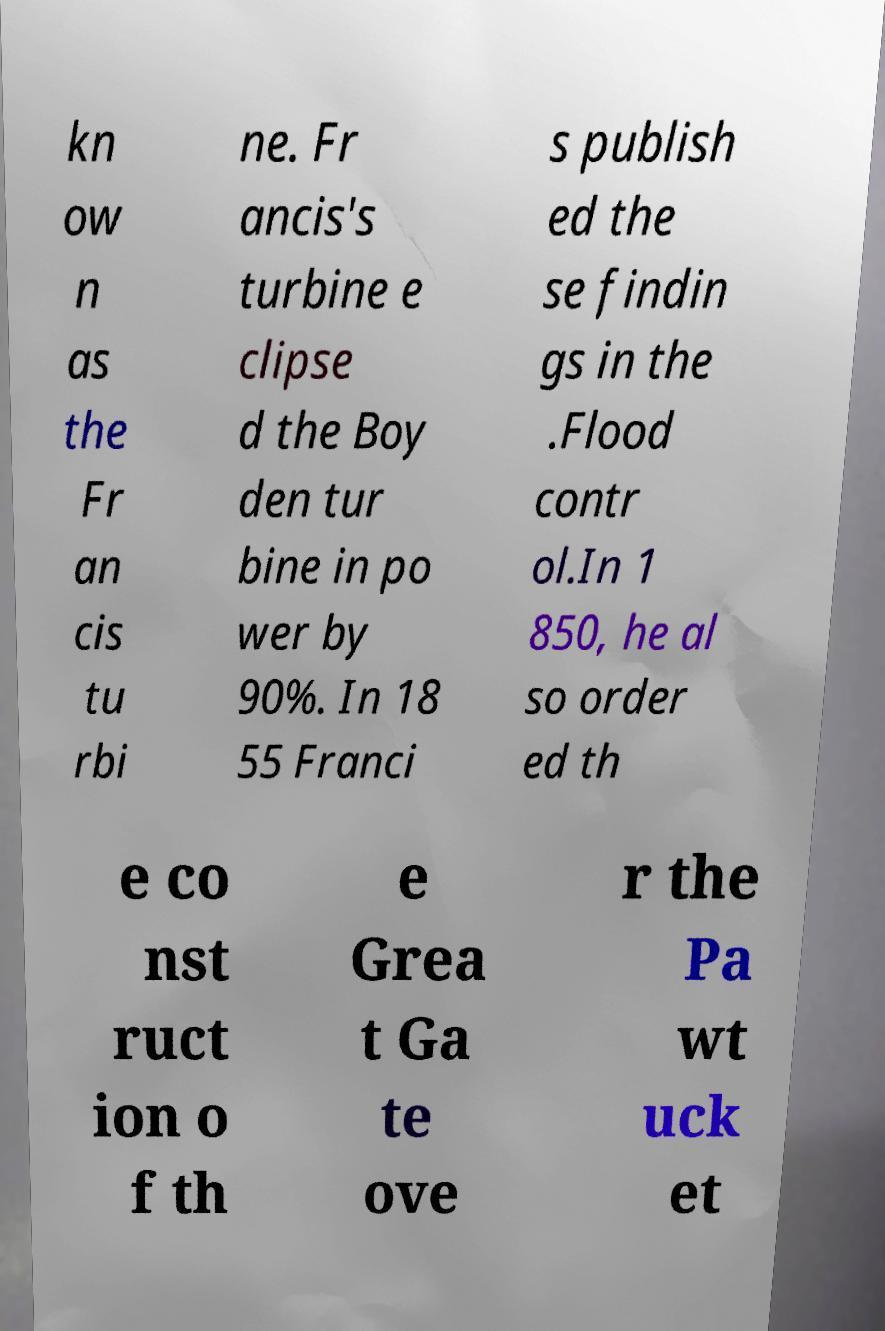What messages or text are displayed in this image? I need them in a readable, typed format. kn ow n as the Fr an cis tu rbi ne. Fr ancis's turbine e clipse d the Boy den tur bine in po wer by 90%. In 18 55 Franci s publish ed the se findin gs in the .Flood contr ol.In 1 850, he al so order ed th e co nst ruct ion o f th e Grea t Ga te ove r the Pa wt uck et 